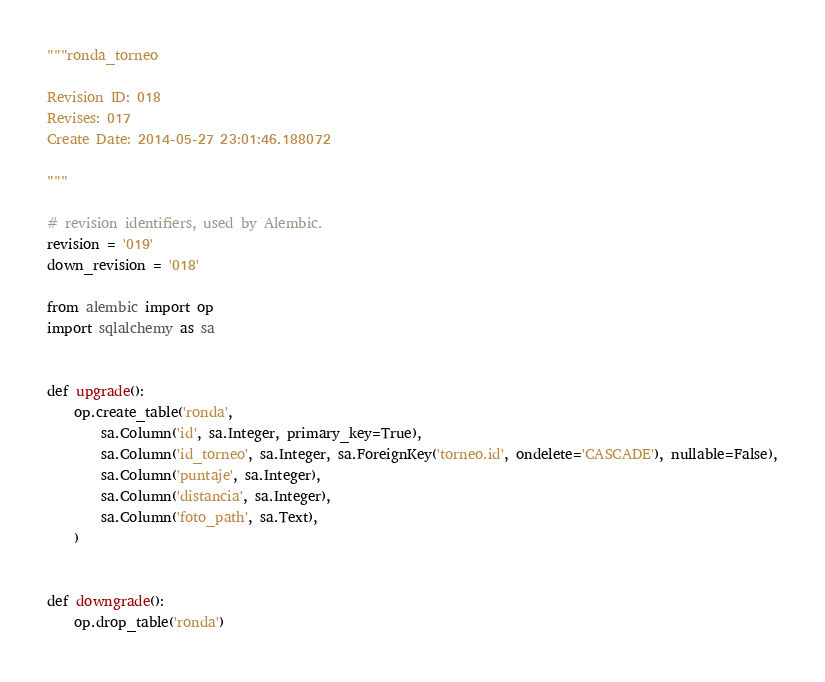<code> <loc_0><loc_0><loc_500><loc_500><_Python_>"""ronda_torneo

Revision ID: 018
Revises: 017
Create Date: 2014-05-27 23:01:46.188072

"""

# revision identifiers, used by Alembic.
revision = '019'
down_revision = '018'

from alembic import op
import sqlalchemy as sa


def upgrade():
    op.create_table('ronda',
        sa.Column('id', sa.Integer, primary_key=True),
        sa.Column('id_torneo', sa.Integer, sa.ForeignKey('torneo.id', ondelete='CASCADE'), nullable=False),
        sa.Column('puntaje', sa.Integer),
        sa.Column('distancia', sa.Integer),
        sa.Column('foto_path', sa.Text),
    )


def downgrade():
    op.drop_table('ronda')
</code> 